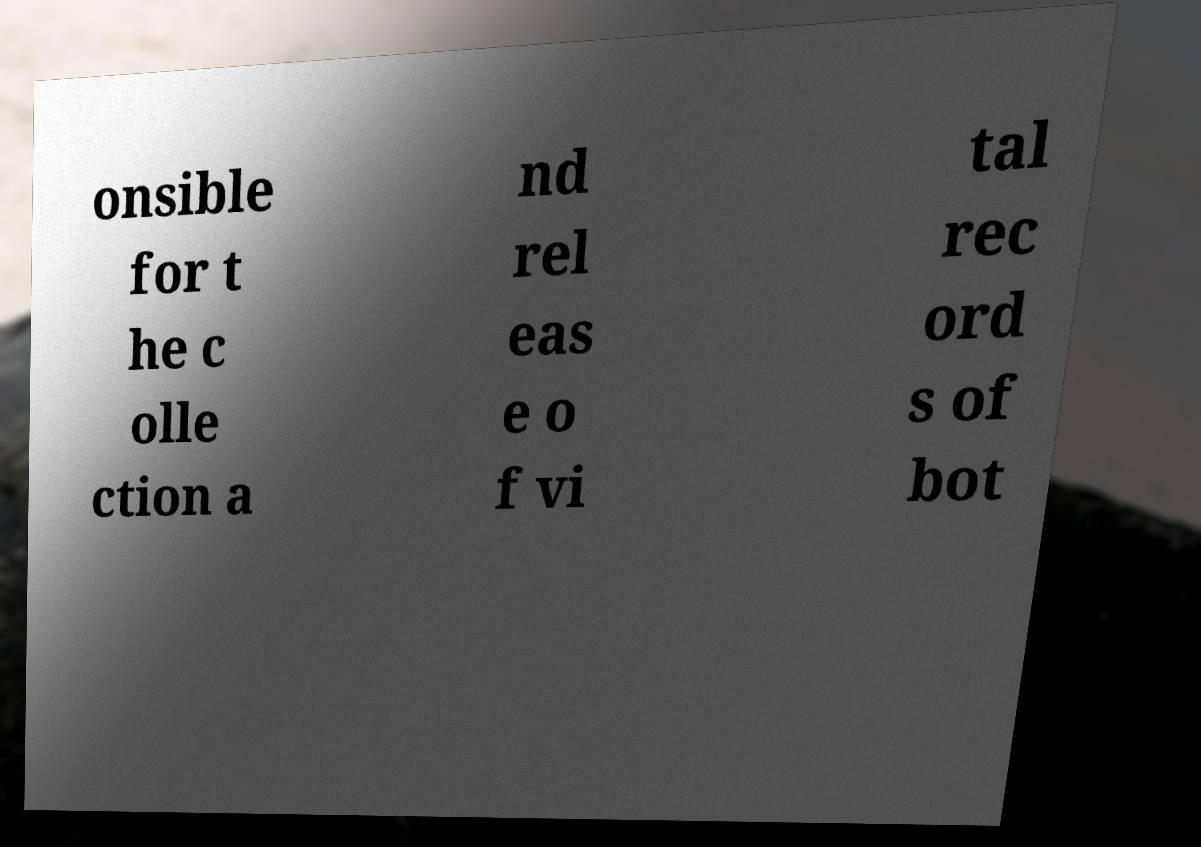Can you read and provide the text displayed in the image?This photo seems to have some interesting text. Can you extract and type it out for me? onsible for t he c olle ction a nd rel eas e o f vi tal rec ord s of bot 